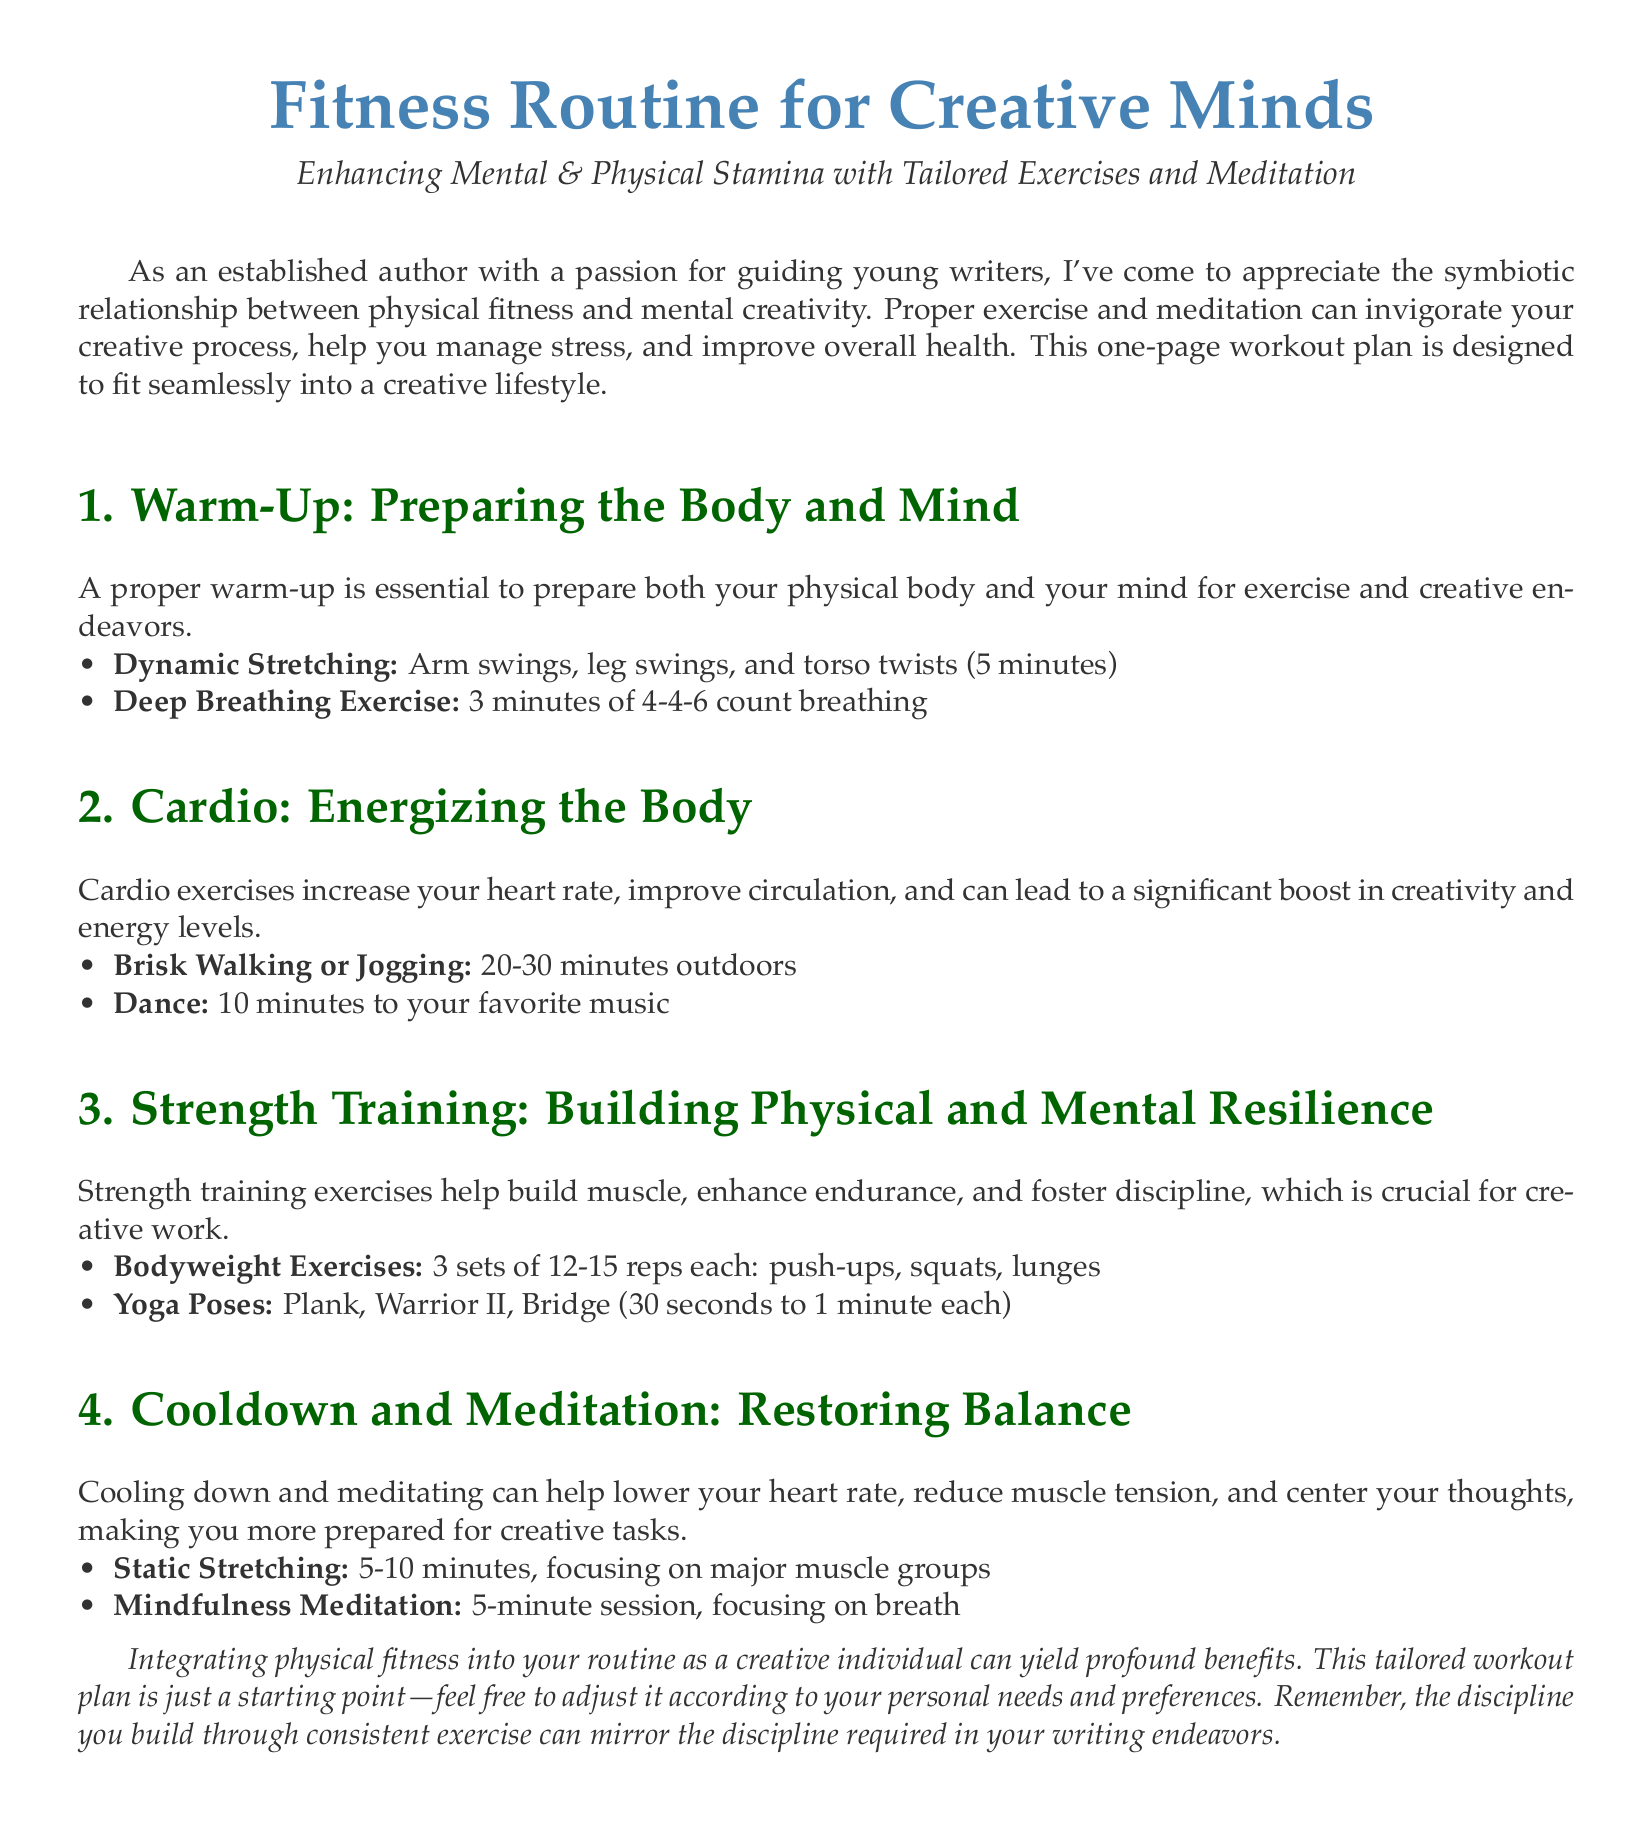What is the main focus of the document? The document concentrates on enhancing mental and physical stamina through exercises and meditation tailored for creative individuals.
Answer: enhancing mental & physical stamina How long should the deep breathing exercise last? The document specifies that the deep breathing exercise should last for 3 minutes.
Answer: 3 minutes What type of cardio exercise is suggested besides brisk walking? Other than brisk walking, dancing is suggested as a cardio exercise in the document.
Answer: Dance How many sets of bodyweight exercises are recommended? The document advises performing 3 sets of each bodyweight exercise.
Answer: 3 sets What is the duration of the mindfulness meditation session? The mindfulness meditation session is suggested to last for 5 minutes.
Answer: 5 minutes Which yoga pose is recommended to enhance discipline for creative work? The document lists several poses, but the Warrior II pose is highlighted for enhancing discipline.
Answer: Warrior II What should be the maximum duration of static stretching? The document recommends static stretching for a maximum duration of 10 minutes.
Answer: 10 minutes What is the purpose of the cooldown and meditation section? The cooldown and meditation section aims to restore balance, lower heart rate, and reduce muscle tension.
Answer: restoring balance What does the author suggest regarding the adjustment of the workout plan? The author encourages individuals to adjust the workout plan according to their personal needs and preferences.
Answer: adjust it according to personal needs and preferences 